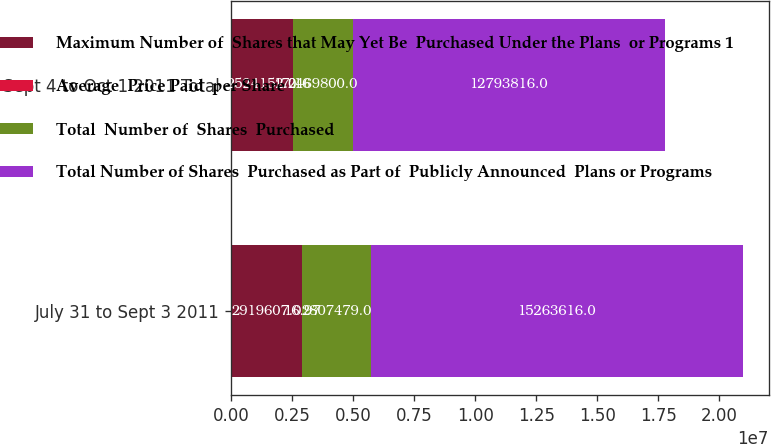Convert chart. <chart><loc_0><loc_0><loc_500><loc_500><stacked_bar_chart><ecel><fcel>July 31 to Sept 3 2011<fcel>Sept 4 to Oct 1 2011 Total<nl><fcel>Maximum Number of  Shares that May Yet Be  Purchased Under the Plans  or Programs 1<fcel>2.91961e+06<fcel>2.52415e+06<nl><fcel>Average  Price Paid  per Share<fcel>16.97<fcel>17.16<nl><fcel>Total  Number of  Shares  Purchased<fcel>2.80748e+06<fcel>2.4698e+06<nl><fcel>Total Number of Shares  Purchased as Part of  Publicly Announced  Plans or Programs<fcel>1.52636e+07<fcel>1.27938e+07<nl></chart> 